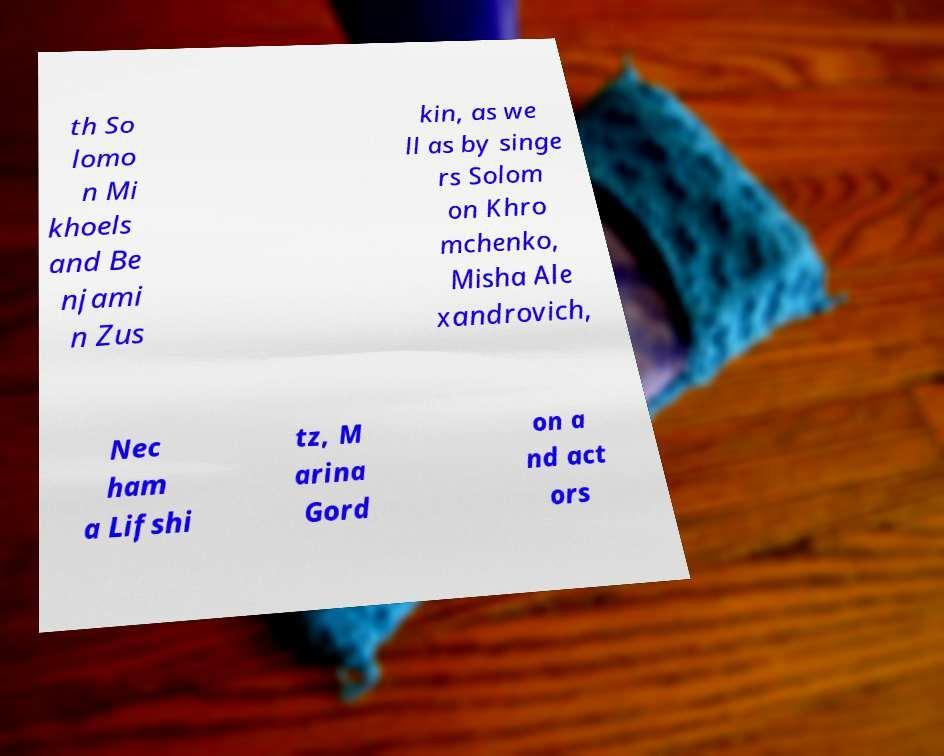Can you accurately transcribe the text from the provided image for me? th So lomo n Mi khoels and Be njami n Zus kin, as we ll as by singe rs Solom on Khro mchenko, Misha Ale xandrovich, Nec ham a Lifshi tz, M arina Gord on a nd act ors 